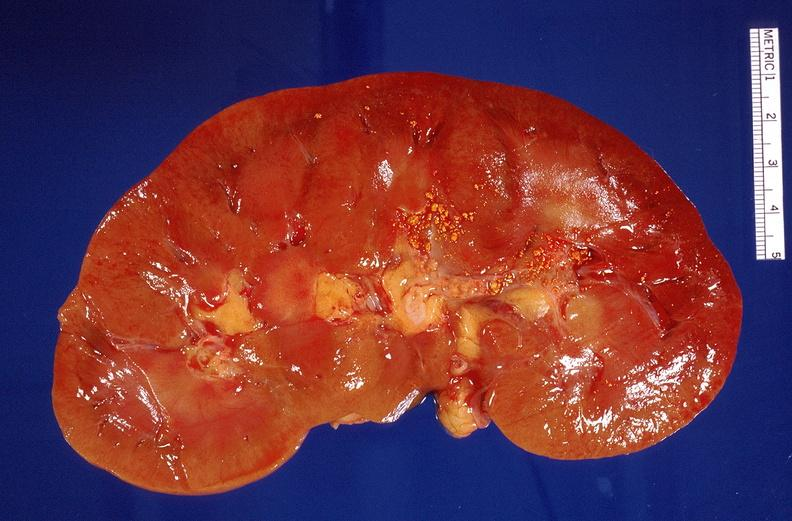does this image show nephrolithiasis?
Answer the question using a single word or phrase. Yes 